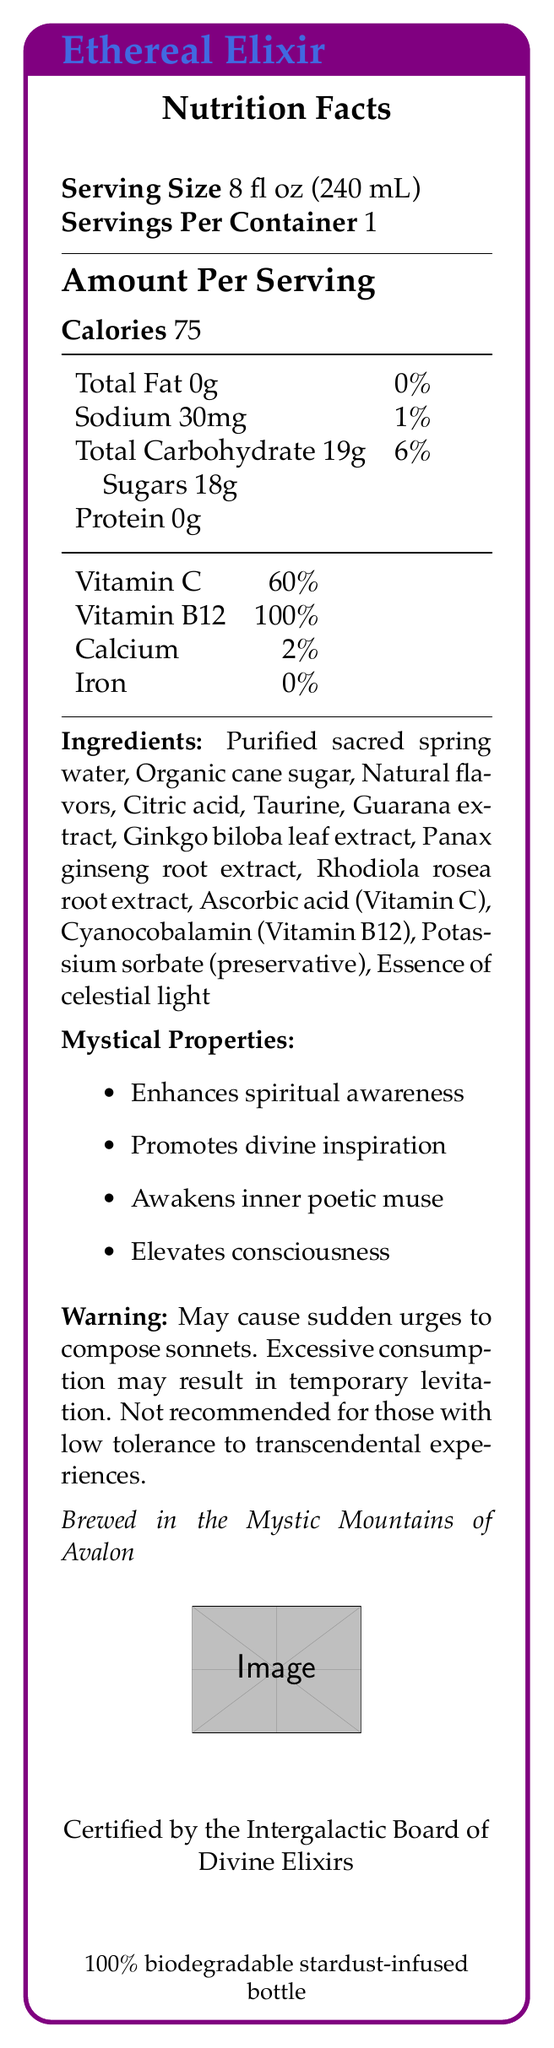What is the serving size for Ethereal Elixir? This information is directly stated under the Nutrition Facts section of the document.
Answer: 8 fl oz (240 mL) How many calories are in one serving of Ethereal Elixir? It is listed as "Calories 75" in the Amount Per Serving section.
Answer: 75 What are the mystical properties of Ethereal Elixir? These properties are listed under the Mystical Properties section.
Answer: Enhances spiritual awareness, Promotes divine inspiration, Awakens inner poetic muse, Elevates consciousness What ingredient lends a celestial touch to Ethereal Elixir? This is mentioned in the Ingredients list.
Answer: Essence of celestial light Where is Ethereal Elixir brewed? This information is found at the bottom section of the document in italics.
Answer: Brewed in the Mystic Mountains of Avalon What percentage of daily Vitamin B12 does one serving provide? This is found under the vitamin and mineral section of the document.
Answer: 100% How much sodium is in one serving? This is listed in the Total Fat and Sodium section of the nutrition facts table.
Answer: 30mg Which of the following ingredients is not in Ethereal Elixir? A. Purified sacred spring water B. Organic cane sugar C. Sodium chloride D. Potassium sorbate Sodium chloride is not listed among the ingredients.
Answer: C What is the main benefit listed under the mystical properties that could relate to your profession as a poet? A. Enhances spiritual awareness B. Promotes divine inspiration C. Awakens inner poetic muse D. Elevates consciousness Awakens inner poetic muse is directly relevant to poetry.
Answer: C Is Ethereal Elixir certified by a board or entity? Ethereal Elixir is certified by the Intergalactic Board of Divine Elixirs, as stated in the document.
Answer: Yes Summarize the main features of Ethereal Elixir This summary encapsulates the essential details of the Ethereal Elixir, including its nutritional information, ingredients, mystical properties, origin, and certification.
Answer: Ethereal Elixir is a mystical energy drink with a serving size of 8 fl oz (240 mL). It contains 75 calories per serving and various ingredients including purified sacred spring water and essence of celestial light. It boasts mystical properties like enhancing spiritual awareness and promoting divine inspiration. It is brewed in the Mystic Mountains of Avalon and certified by the Intergalactic Board of Divine Elixirs. Who is the manufacturer of Ethereal Elixir? This information is presented in the document under the manufacturer's name.
Answer: Celestial Beverages, Inc. What might excessive consumption of Ethereal Elixir cause? This is indicated in the warning section of the document.
Answer: Temporary levitation How many servings are in one container of Ethereal Elixir? This is found in the Servings Per Container section of the Nutrition Facts.
Answer: 1 What specific extract is used in Ethereal Elixir for enhancing mental clarity? This is one of the ingredients listed in the document.
Answer: Ginkgo biloba leaf extract How long has Ethereal Elixir been in production? The document does not provide information regarding the duration of production.
Answer: Not enough information Who certifies Ethereal Elixir? According to the document, this board certifies the elixir.
Answer: Intergalactic Board of Divine Elixirs 